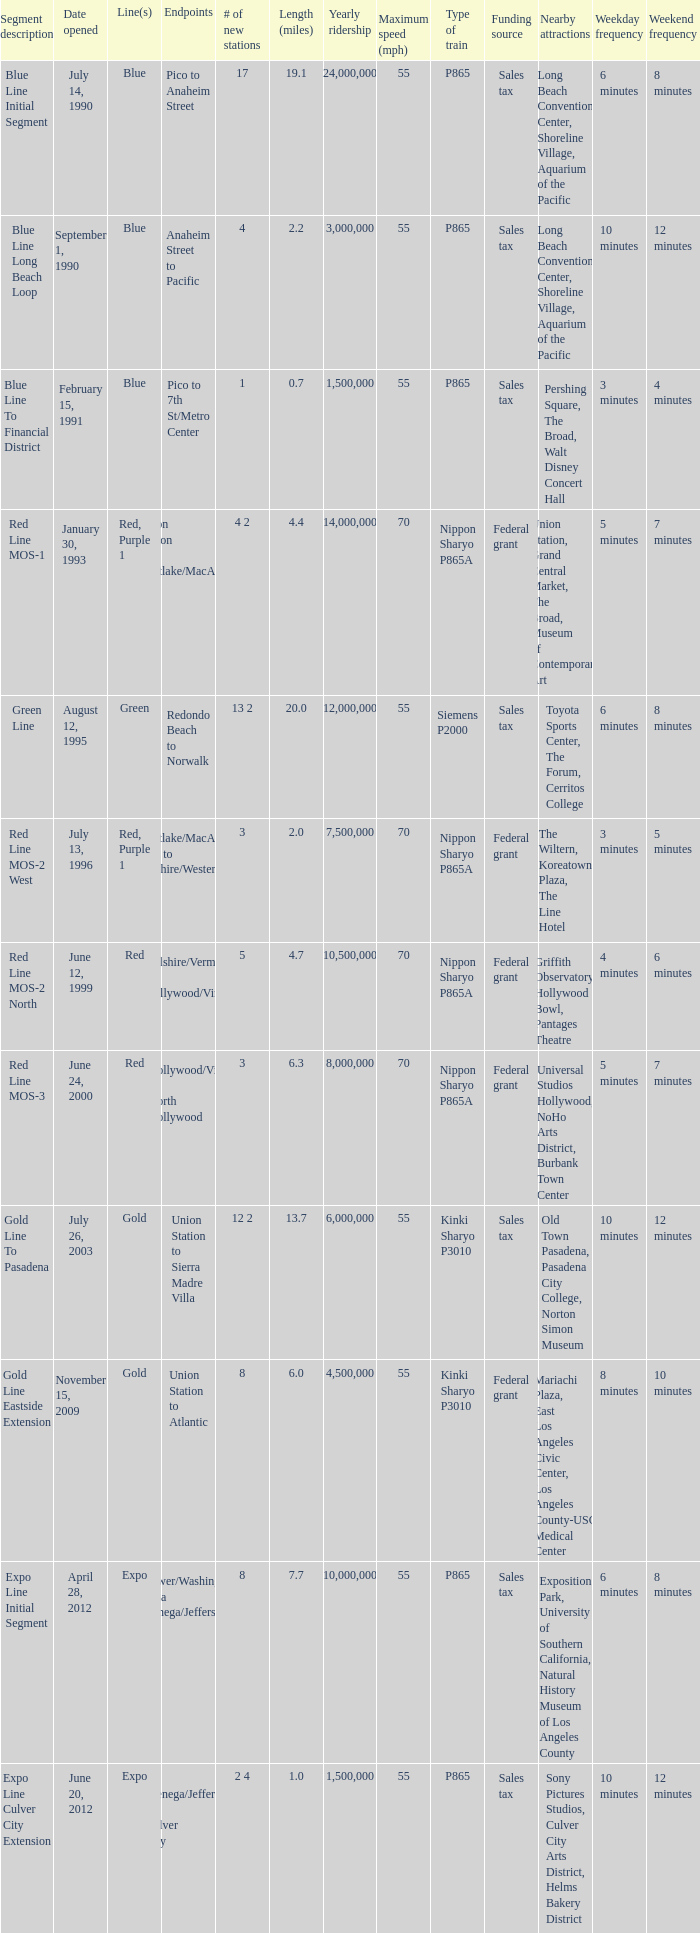How many news stations opened on the date of June 24, 2000? 3.0. Could you help me parse every detail presented in this table? {'header': ['Segment description', 'Date opened', 'Line(s)', 'Endpoints', '# of new stations', 'Length (miles)', 'Yearly ridership', 'Maximum speed (mph)', 'Type of train', 'Funding source', 'Nearby attractions', 'Weekday frequency', 'Weekend frequency'], 'rows': [['Blue Line Initial Segment', 'July 14, 1990', 'Blue', 'Pico to Anaheim Street', '17', '19.1', '24,000,000', '55', 'P865', 'Sales tax', 'Long Beach Convention Center, Shoreline Village, Aquarium of the Pacific', '6 minutes', '8 minutes'], ['Blue Line Long Beach Loop', 'September 1, 1990', 'Blue', 'Anaheim Street to Pacific', '4', '2.2', '3,000,000', '55', 'P865', 'Sales tax', 'Long Beach Convention Center, Shoreline Village, Aquarium of the Pacific', '10 minutes', '12 minutes'], ['Blue Line To Financial District', 'February 15, 1991', 'Blue', 'Pico to 7th St/Metro Center', '1', '0.7', '1,500,000', '55', 'P865', 'Sales tax', 'Pershing Square, The Broad, Walt Disney Concert Hall', '3 minutes', '4 minutes'], ['Red Line MOS-1', 'January 30, 1993', 'Red, Purple 1', 'Union Station to Westlake/MacArthur Park', '4 2', '4.4', '14,000,000', '70', 'Nippon Sharyo P865A', 'Federal grant', 'Union Station, Grand Central Market, The Broad, Museum of Contemporary Art', '5 minutes', '7 minutes'], ['Green Line', 'August 12, 1995', 'Green', 'Redondo Beach to Norwalk', '13 2', '20.0', '12,000,000', '55', 'Siemens P2000', 'Sales tax', 'Toyota Sports Center, The Forum, Cerritos College', '6 minutes', '8 minutes'], ['Red Line MOS-2 West', 'July 13, 1996', 'Red, Purple 1', 'Westlake/MacArthur Park to Wilshire/Western', '3', '2.0', '7,500,000', '70', 'Nippon Sharyo P865A', 'Federal grant', 'The Wiltern, Koreatown Plaza, The Line Hotel', '3 minutes', '5 minutes'], ['Red Line MOS-2 North', 'June 12, 1999', 'Red', 'Wilshire/Vermont to Hollywood/Vine', '5', '4.7', '10,500,000', '70', 'Nippon Sharyo P865A', 'Federal grant', 'Griffith Observatory, Hollywood Bowl, Pantages Theatre', '4 minutes', '6 minutes'], ['Red Line MOS-3', 'June 24, 2000', 'Red', 'Hollywood/Vine to North Hollywood', '3', '6.3', '8,000,000', '70', 'Nippon Sharyo P865A', 'Federal grant', 'Universal Studios Hollywood, NoHo Arts District, Burbank Town Center', '5 minutes', '7 minutes'], ['Gold Line To Pasadena', 'July 26, 2003', 'Gold', 'Union Station to Sierra Madre Villa', '12 2', '13.7', '6,000,000', '55', 'Kinki Sharyo P3010', 'Sales tax', 'Old Town Pasadena, Pasadena City College, Norton Simon Museum', '10 minutes', '12 minutes'], ['Gold Line Eastside Extension', 'November 15, 2009', 'Gold', 'Union Station to Atlantic', '8', '6.0', '4,500,000', '55', 'Kinki Sharyo P3010', 'Federal grant', 'Mariachi Plaza, East Los Angeles Civic Center, Los Angeles County-USC Medical Center', '8 minutes', '10 minutes'], ['Expo Line Initial Segment', 'April 28, 2012', 'Expo', 'Flower/Washington to La Cienega/Jefferson 3', '8', '7.7', '10,000,000', '55', 'P865', 'Sales tax', 'Exposition Park, University of Southern California, Natural History Museum of Los Angeles County', '6 minutes', '8 minutes'], ['Expo Line Culver City Extension', 'June 20, 2012', 'Expo', 'La Cienega/Jefferson to Culver City', '2 4', '1.0', '1,500,000', '55', 'P865', 'Sales tax', 'Sony Pictures Studios, Culver City Arts District, Helms Bakery District', '10 minutes', '12 minutes']]} 